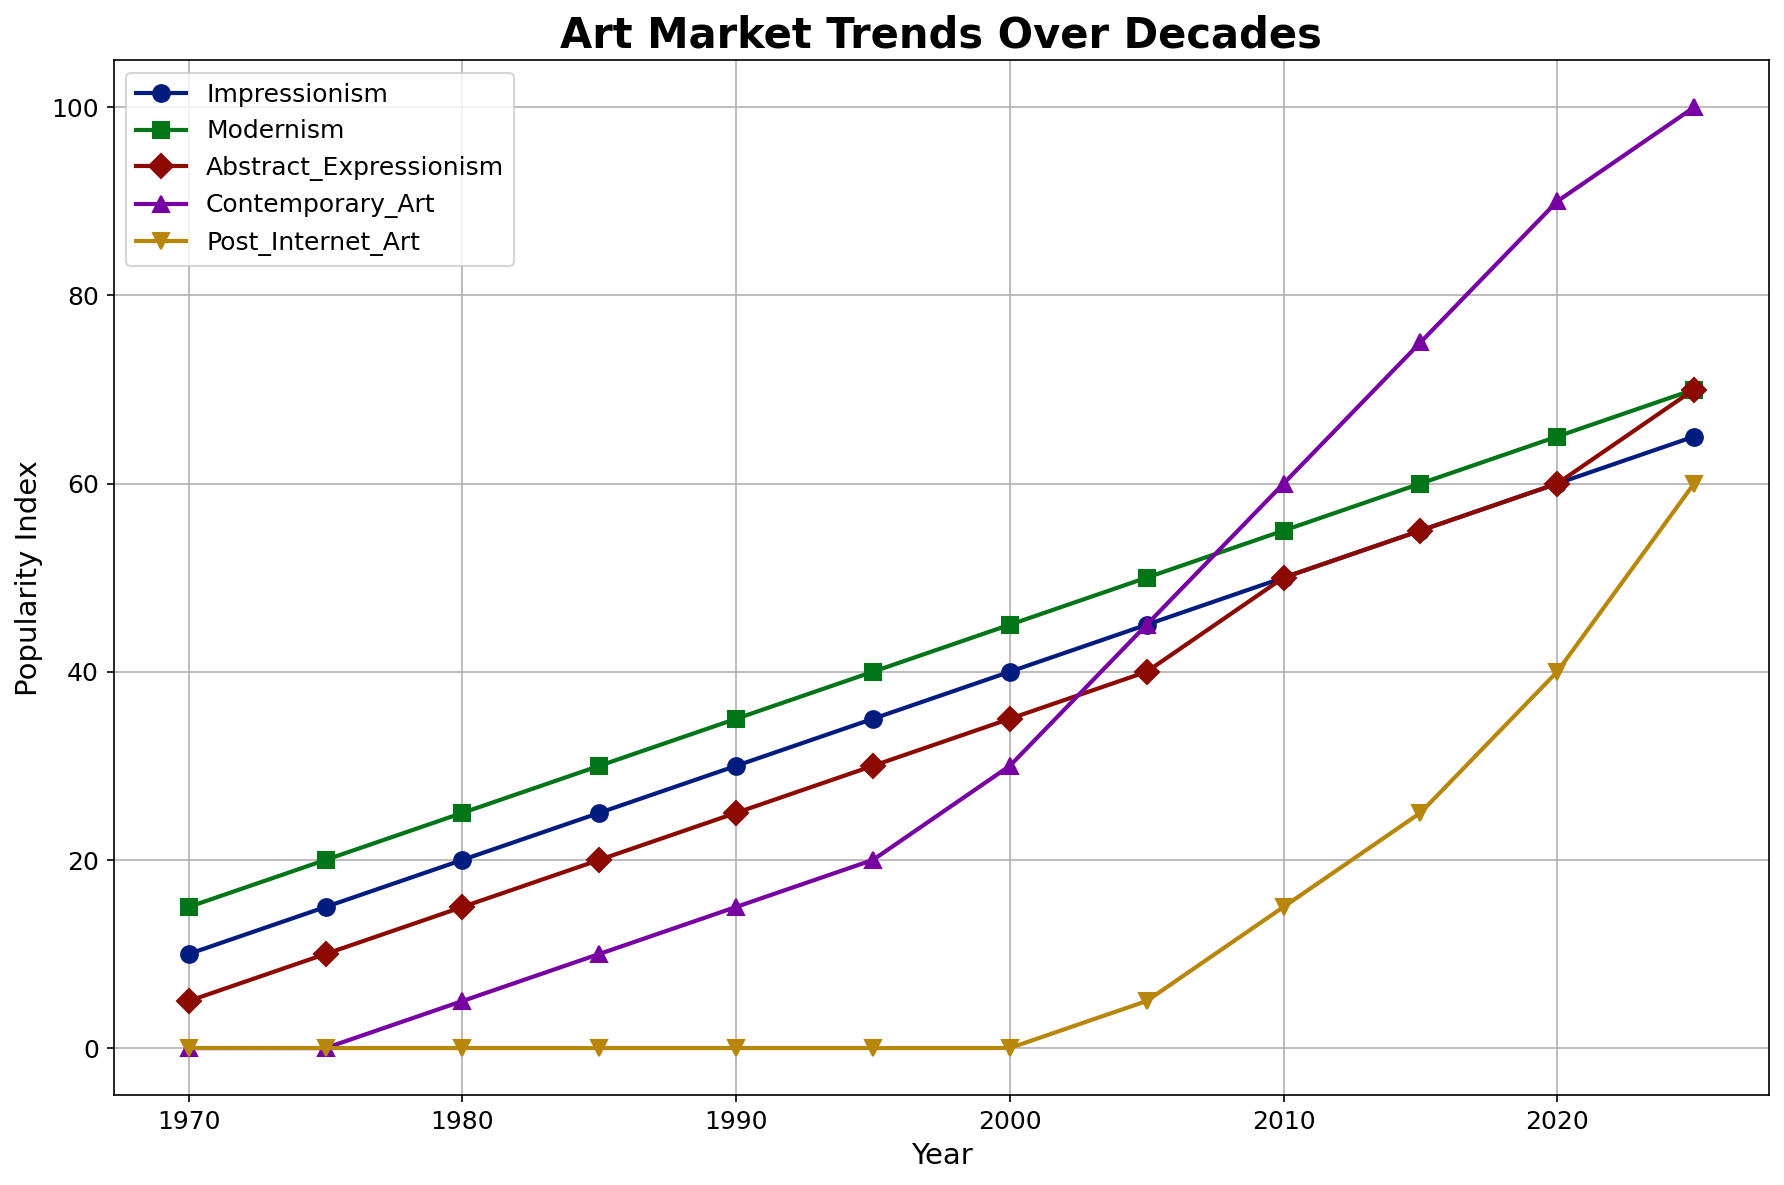Which art movement had the highest popularity index in 2025? The figure shows popularity indices for different art movements across various years. In 2025, Contemporary Art reaches the highest point on the y-axis, indicating it has the highest popularity index.
Answer: Contemporary Art Between 1970 and 1980, which art movement had the greatest increase in popularity? Looking at the starting and ending points between 1970 and 1980, Impressionism goes from 10 to 20, Modernism from 15 to 25, Abstract Expressionism from 5 to 15, and Contemporary Art remains at 0. The increase for Abstract Expressionism is 10, which is the greatest.
Answer: Abstract Expressionism By how much did Contemporary Art's popularity index increase from 1980 to 2025? Contemporary Art's index in 1980 is 5; in 2025, it's 100. The increase is 100 - 5 = 95.
Answer: 95 What is the average popularity index of Modernism from 1970 to 2025? Summing the indices for Modernism from 1970 to 2025: 15, 20, 25, 30, 35, 40, 45, 50, 55, 60, 65, 70, gives a total of 510. Dividing by the number of years (12), the average is 510 / 12 = 42.5.
Answer: 42.5 Which art movement showed the most rapid growth during the 2010-2020 period? Reviewing the slopes between 2010 and 2020, Contemporary Art rises from 60 to 90, increasing by 30. Post-Internet Art rises from 15 to 40, increasing by 25. Contemporary Art shows the most rapid growth with an increase of 30.
Answer: Contemporary Art How does the popularity of Impressionism in 2020 compare with Abstract Expressionism in 1990? Impressionism in 2020 is at 60, while Abstract Expressionism in 1990 is at 25. Impressionism’s popularity in 2020 is higher.
Answer: Higher Which art movement gained popularity first, Contemporary Art or Post-Internet Art, and in which year did this happen? Contemporary Art starts gaining popularity in 1980 (index of 5), while Post-Internet Art starts in 2005 (index of 5). Contemporary Art gained popularity first in 1980.
Answer: Contemporary Art in 1980 By how many points does Impressionism's popularity index increase from 1995 to 2020? Impressionism's index in 1995 is 35 and in 2020 is 60. The increase is 60 - 35 = 25 points.
Answer: 25 In which years did the popularity index of Modernism reach 55? Checking the data for Modernism, its index reaches 55 in 2010.
Answer: 2010 